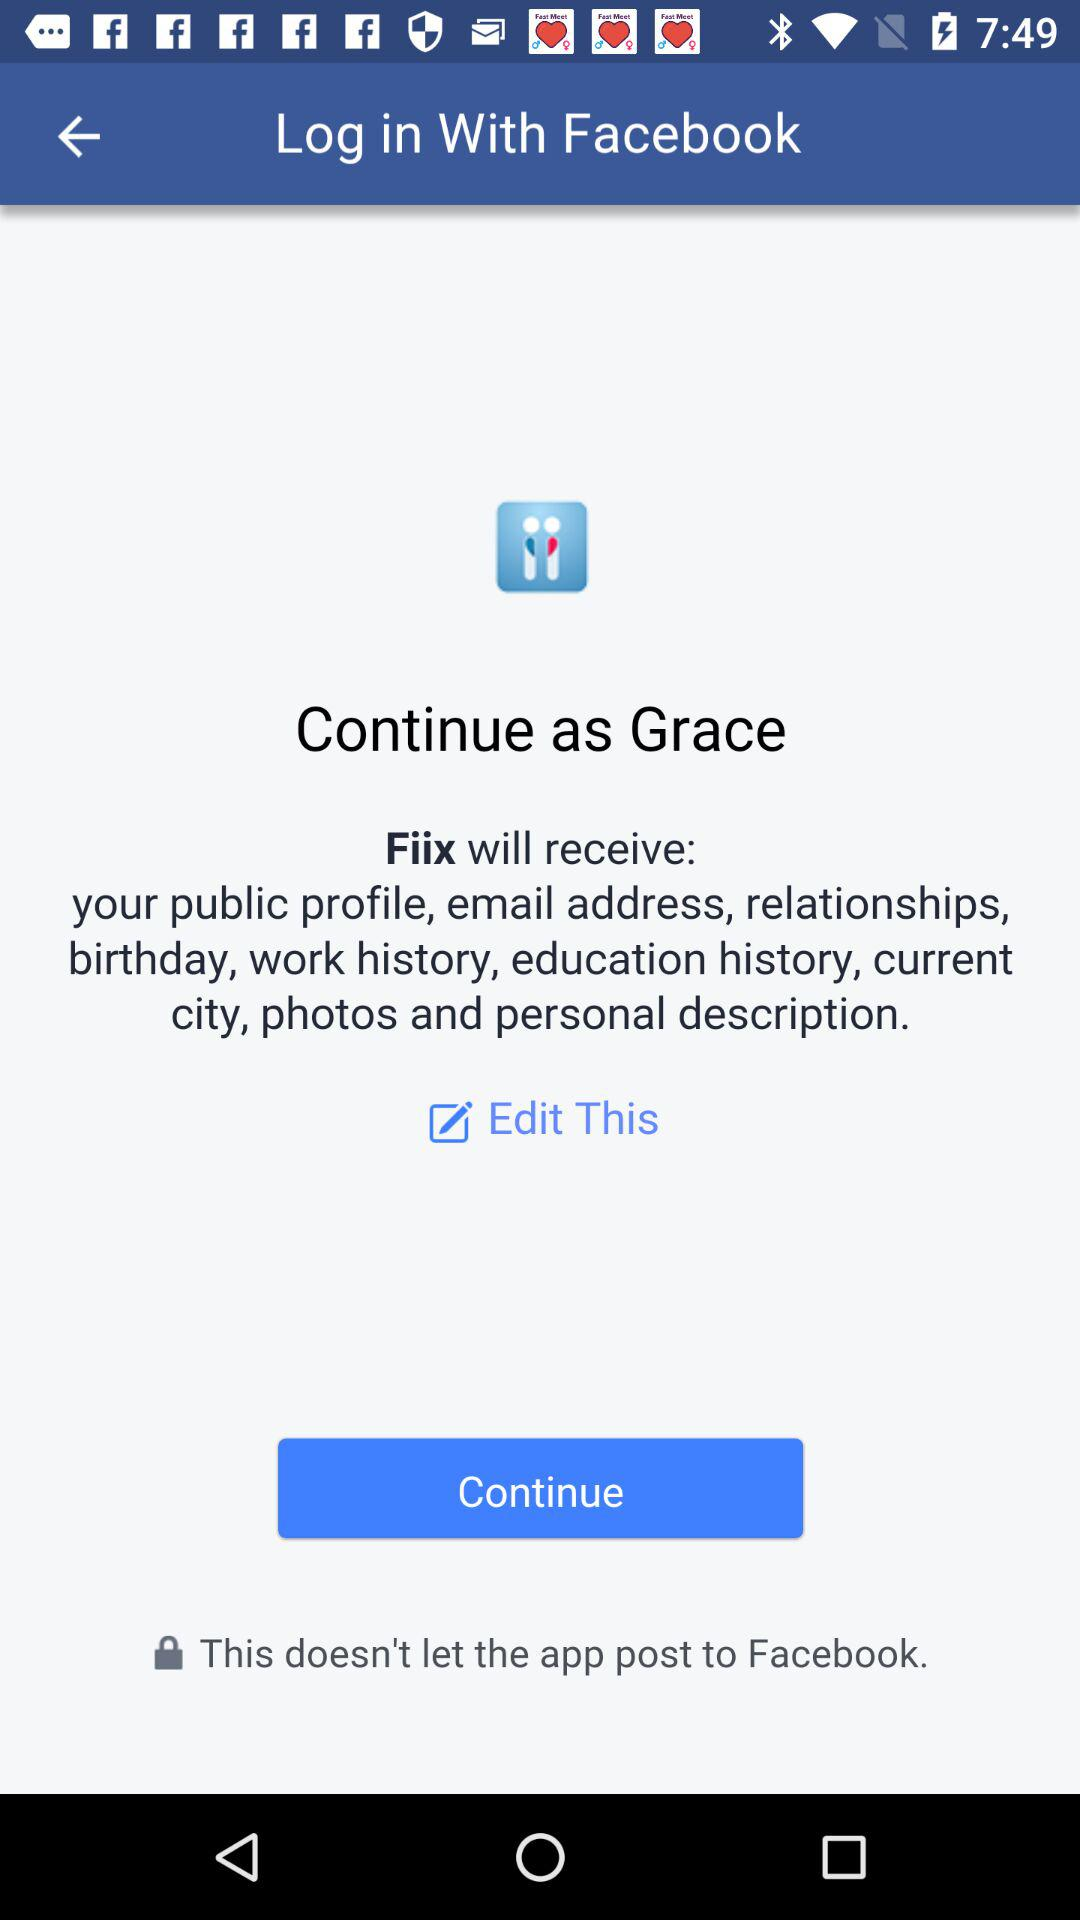What is the user name to continue with the profile? The user name is Grace. 